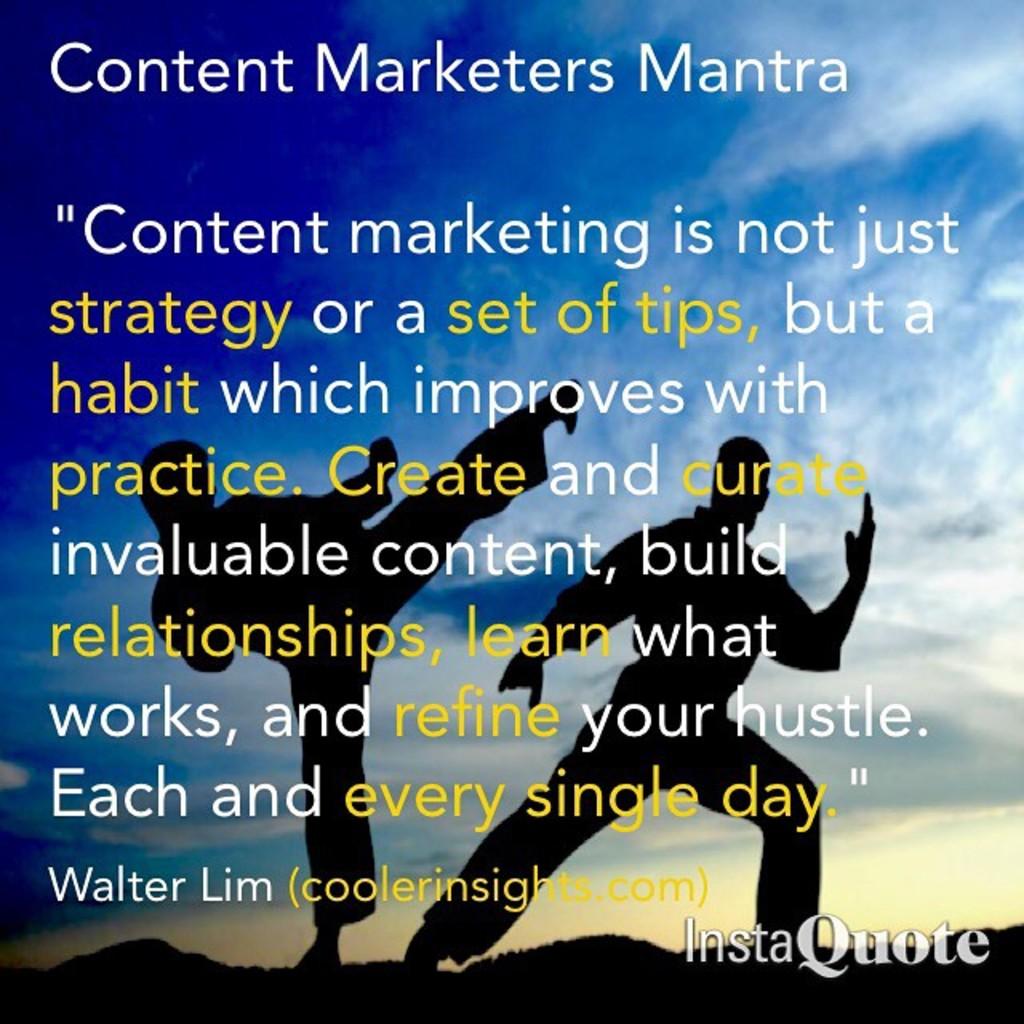What is the name of the person being quoted?
Offer a very short reply. Walter lim. Is this an instaquote by walter lim?
Your answer should be very brief. Yes. 